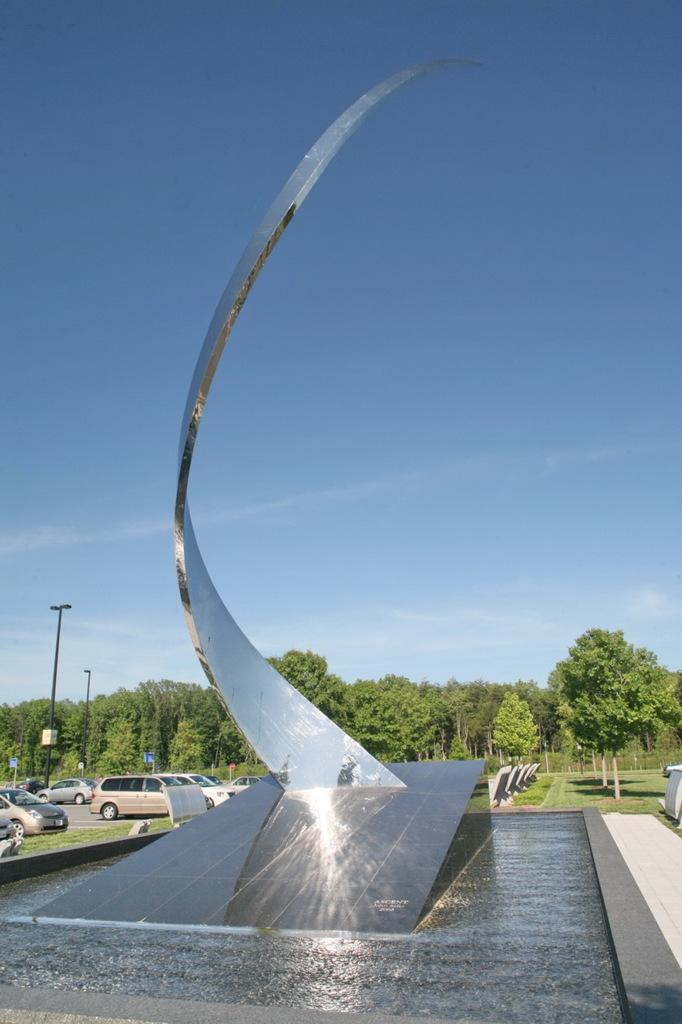What is located on the ground in the image? There is an object on the ground in the image. What can be seen in the distance behind the object? There are vehicles, trees, poles, and the sky visible in the background of the image. How does the ocean affect the grade of the object in the image? There is no ocean present in the image, so it cannot affect the grade of the object. 